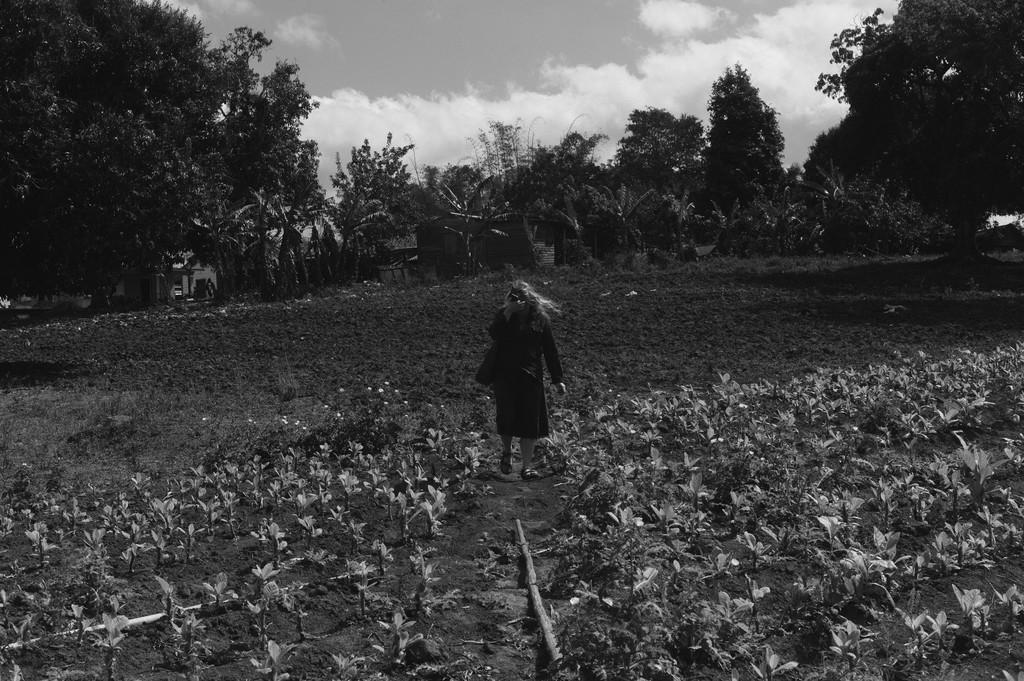What is the color scheme of the image? The image is black and white. Can you describe the person in the image? There is a person standing in the image. What type of vegetation can be seen in the image? There is a group of plants with flowers and a group of trees in the image. What is the ground made of in the image? There is mud visible in the image. What is visible in the sky in the image? The sky is visible in the image and appears cloudy. How does the person in the image connect to the internet? There is no information about internet connectivity in the image, as it is a black and white image of a person standing with plants and trees. What type of body is present in the image? The image does not depict any bodies, as it is a scene in nature with a person, plants, trees, and mud. 